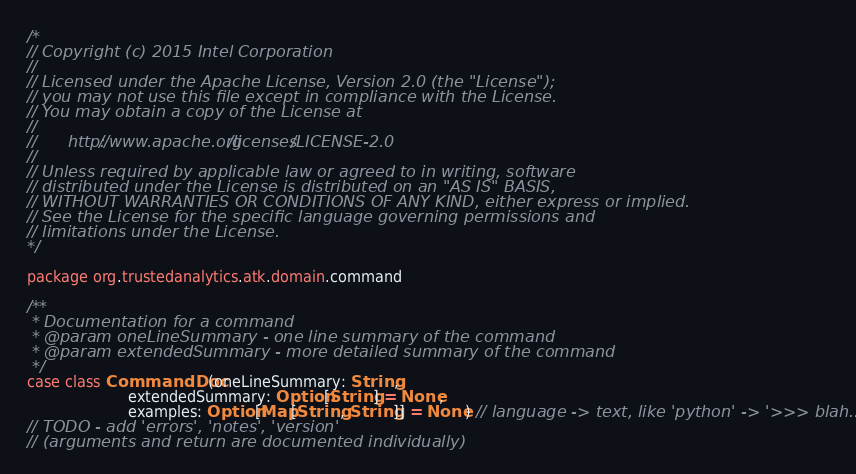<code> <loc_0><loc_0><loc_500><loc_500><_Scala_>/*
// Copyright (c) 2015 Intel Corporation 
//
// Licensed under the Apache License, Version 2.0 (the "License");
// you may not use this file except in compliance with the License.
// You may obtain a copy of the License at
//
//      http://www.apache.org/licenses/LICENSE-2.0
//
// Unless required by applicable law or agreed to in writing, software
// distributed under the License is distributed on an "AS IS" BASIS,
// WITHOUT WARRANTIES OR CONDITIONS OF ANY KIND, either express or implied.
// See the License for the specific language governing permissions and
// limitations under the License.
*/

package org.trustedanalytics.atk.domain.command

/**
 * Documentation for a command
 * @param oneLineSummary - one line summary of the command
 * @param extendedSummary - more detailed summary of the command
 */
case class CommandDoc(oneLineSummary: String,
                      extendedSummary: Option[String] = None,
                      examples: Option[Map[String, String]] = None) // language -> text, like 'python' -> '>>> blah...'
// TODO - add 'errors', 'notes', 'version'
// (arguments and return are documented individually)
</code> 